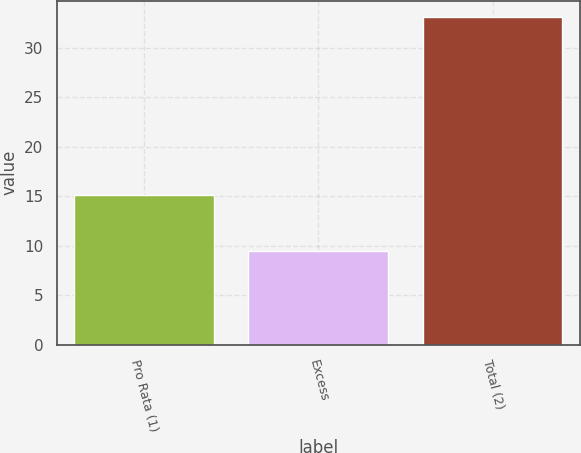Convert chart. <chart><loc_0><loc_0><loc_500><loc_500><bar_chart><fcel>Pro Rata (1)<fcel>Excess<fcel>Total (2)<nl><fcel>15.1<fcel>9.5<fcel>33.1<nl></chart> 